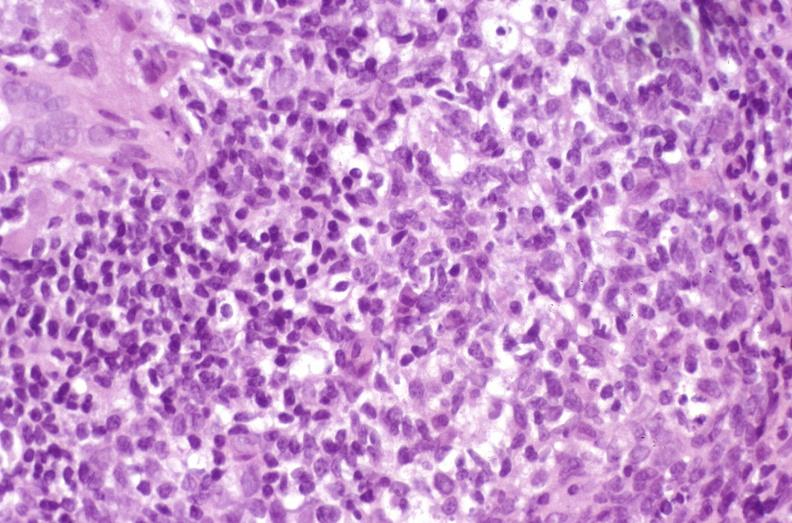does this image show recurrent hepatitis c virus?
Answer the question using a single word or phrase. Yes 